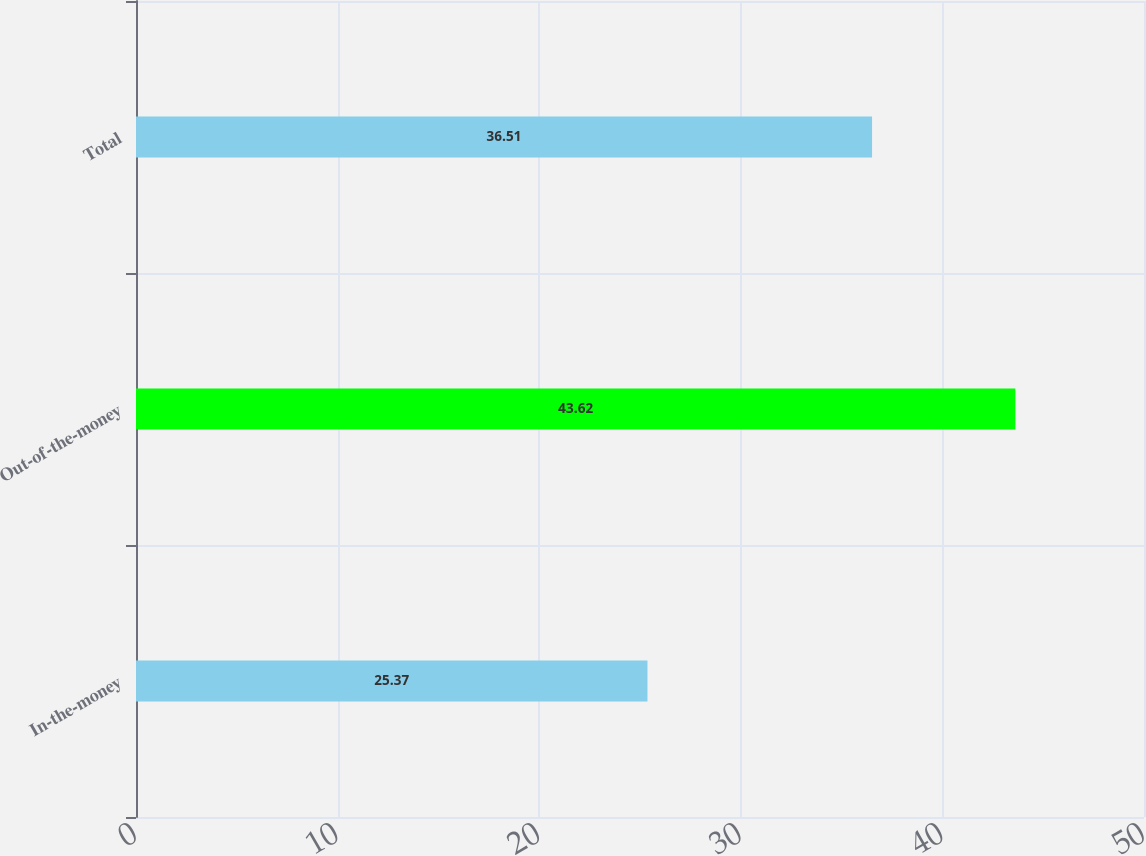Convert chart. <chart><loc_0><loc_0><loc_500><loc_500><bar_chart><fcel>In-the-money<fcel>Out-of-the-money<fcel>Total<nl><fcel>25.37<fcel>43.62<fcel>36.51<nl></chart> 